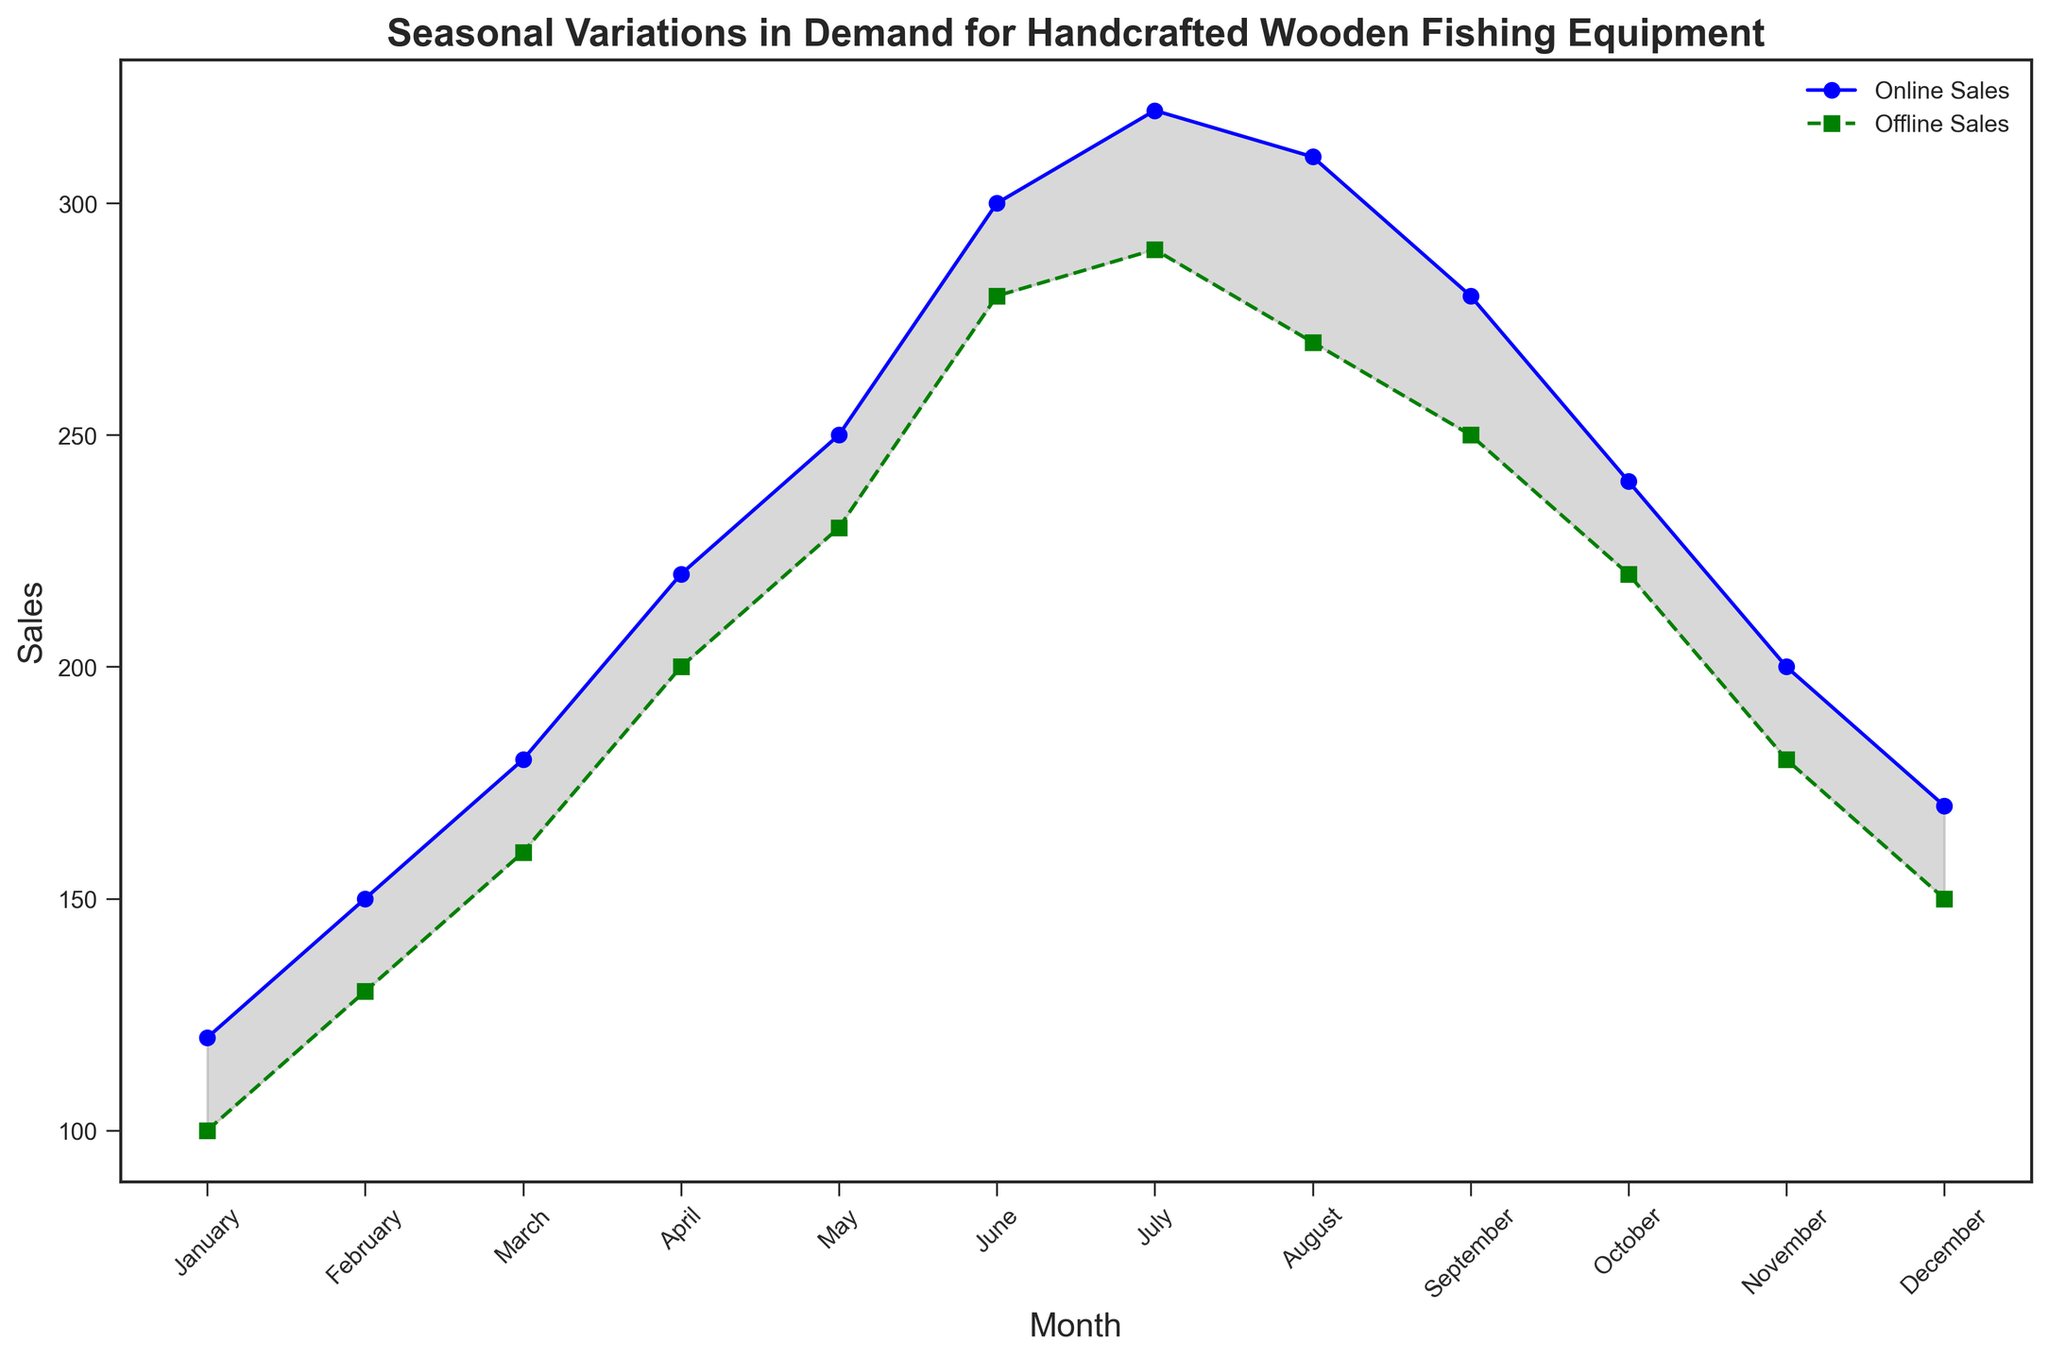What month has the highest online sales? Reach the peak of the online sales line, which occurs in July where the blue line is the highest.
Answer: July What is the difference in sales between online and offline channels in May? Check both sales values for May; online sales are 250 and offline sales are 230. Subtract the offline sales from the online sales: 250 - 230 = 20.
Answer: 20 In which month do online sales start to decline? Observe that online sales begin to decrease after peaking in July. The decline begins in August.
Answer: August Which month shows the smallest gap between online and offline sales? Visualize the area filled in gray between the lines, and find where the gray area is narrowest. This appears to be in January where the difference is 120 - 100 = 20.
Answer: January During which months do online sales exceed offline sales by at least 50 units? Compare the values of online and offline sales for each month to identify when the difference is at least 50: June, July, and August meet this criterion.
Answer: June, July, August During which month do offline sales reach their maximum? Reach the peak of the offline sales line, which occurs in July where the green line is the highest.
Answer: July What is the total sales (online and offline) in March? Add the online sales in March (180) to the offline sales in March (160): 180 + 160 = 340.
Answer: 340 How does the trend of offline sales differ from online sales between June and September? From June to September, online sales show a peak in July and decline afterward, while offline sales also peak in July but show a more gradual decline.
Answer: Online sales peak and decline sharply; offline sales peak and decline gradually 